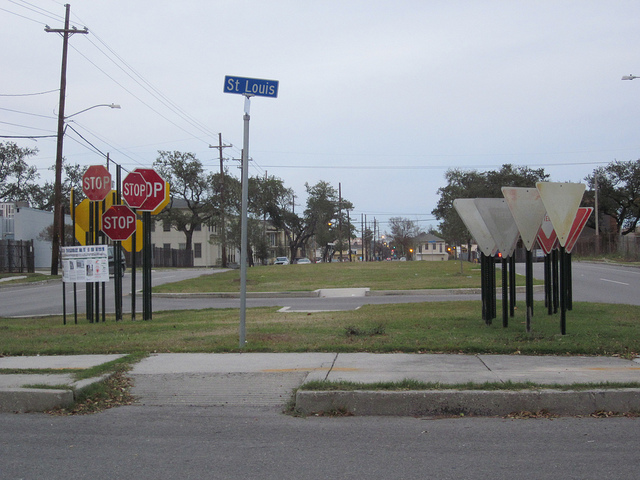Identify and read out the text in this image. St Louis STOP STOP STOP OP 